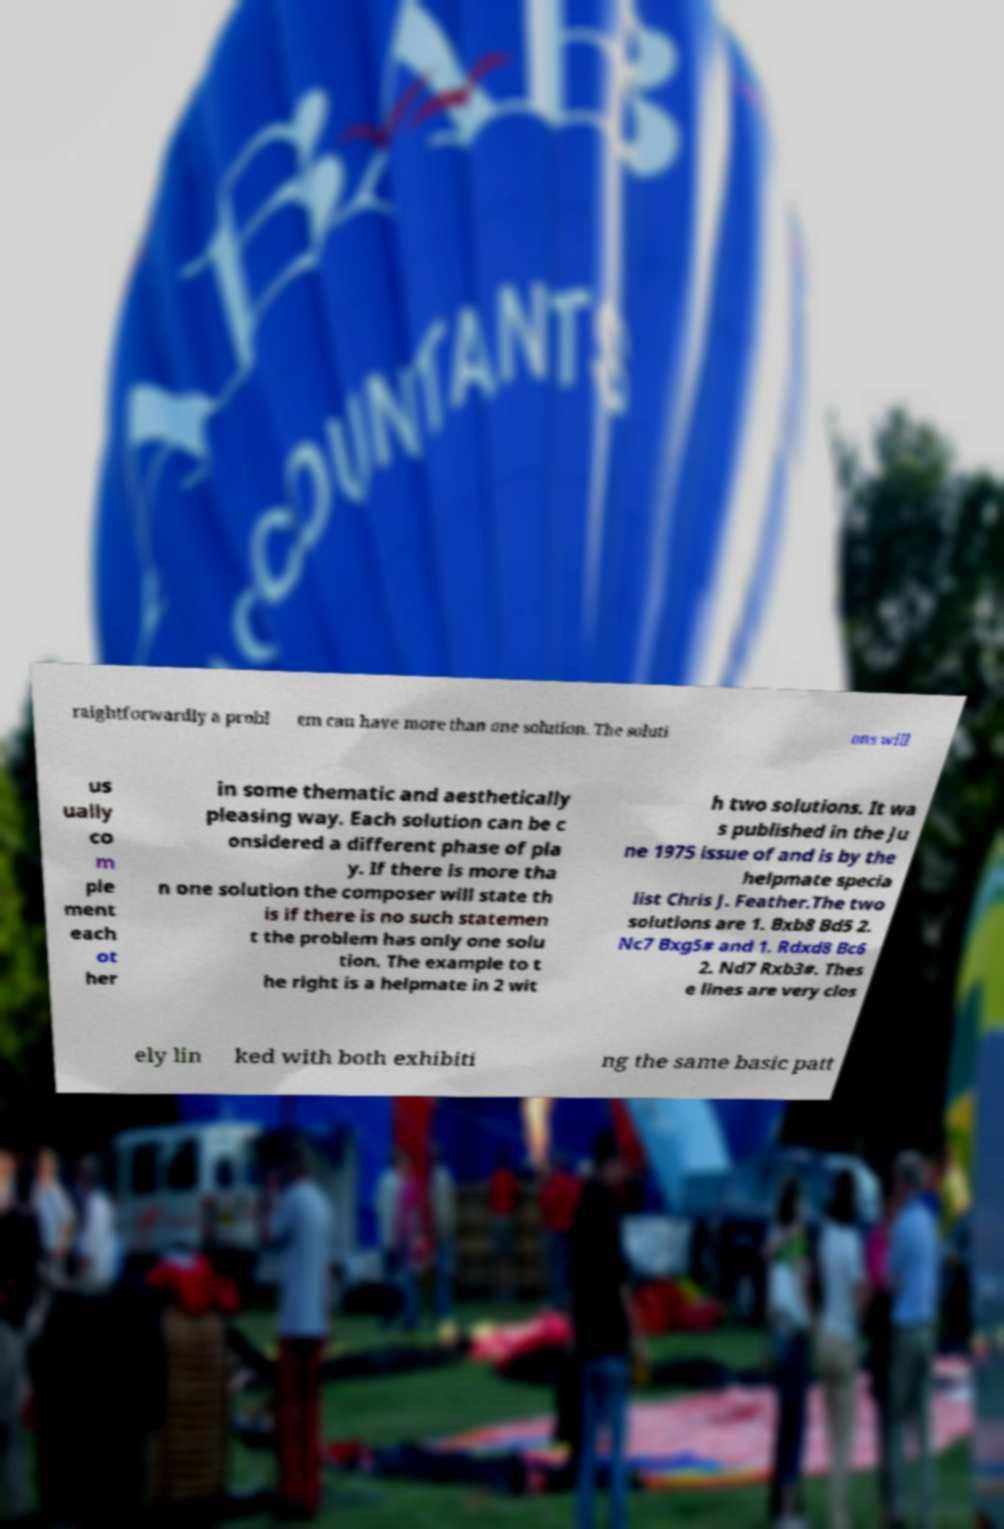What messages or text are displayed in this image? I need them in a readable, typed format. raightforwardly a probl em can have more than one solution. The soluti ons will us ually co m ple ment each ot her in some thematic and aesthetically pleasing way. Each solution can be c onsidered a different phase of pla y. If there is more tha n one solution the composer will state th is if there is no such statemen t the problem has only one solu tion. The example to t he right is a helpmate in 2 wit h two solutions. It wa s published in the Ju ne 1975 issue of and is by the helpmate specia list Chris J. Feather.The two solutions are 1. Bxb8 Bd5 2. Nc7 Bxg5# and 1. Rdxd8 Bc6 2. Nd7 Rxb3#. Thes e lines are very clos ely lin ked with both exhibiti ng the same basic patt 